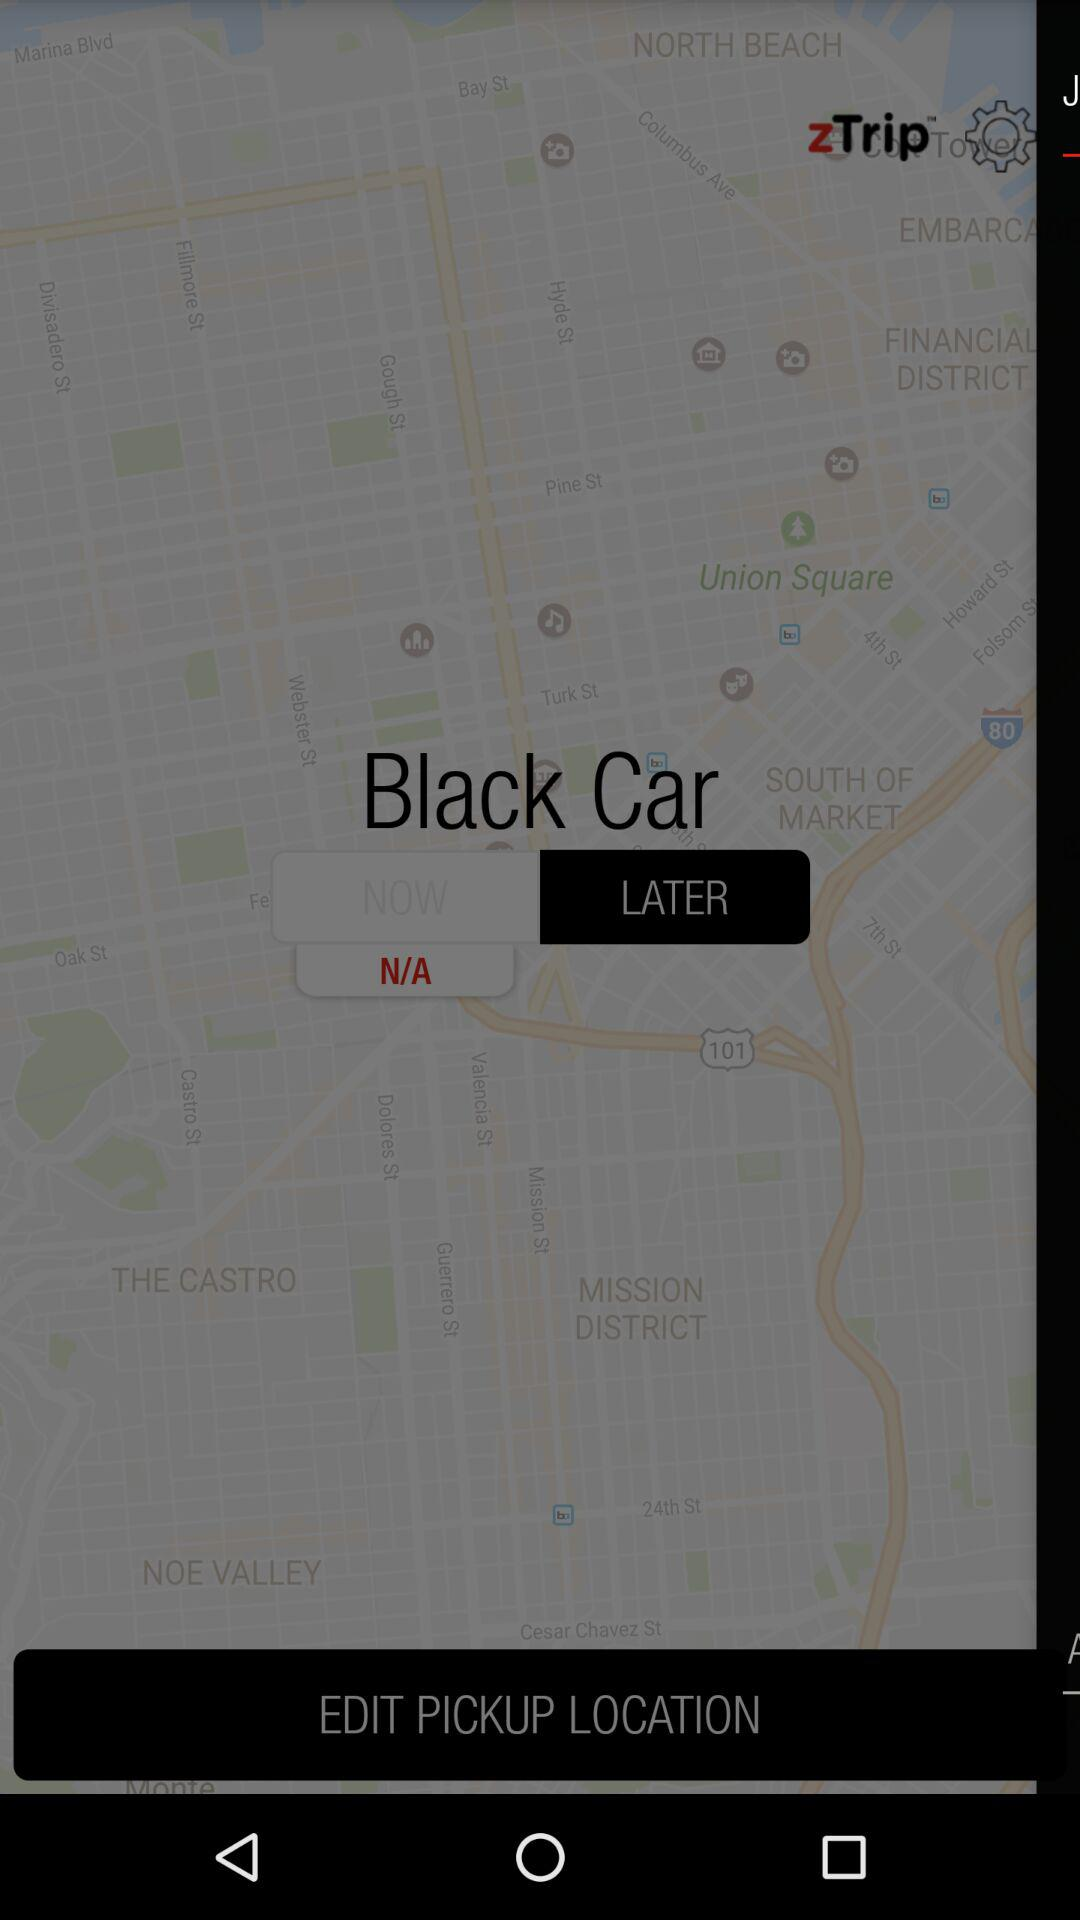What is the name of the application? The name of the application is "zTrip". 